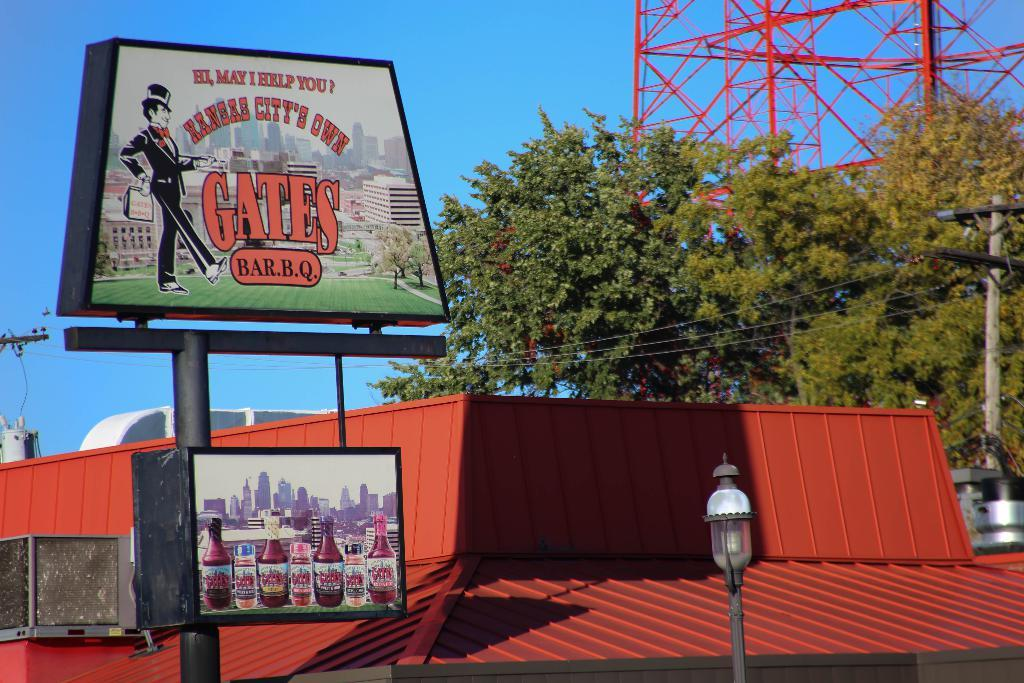<image>
Summarize the visual content of the image. A billboard for Kansas City's own Gates BBQ 